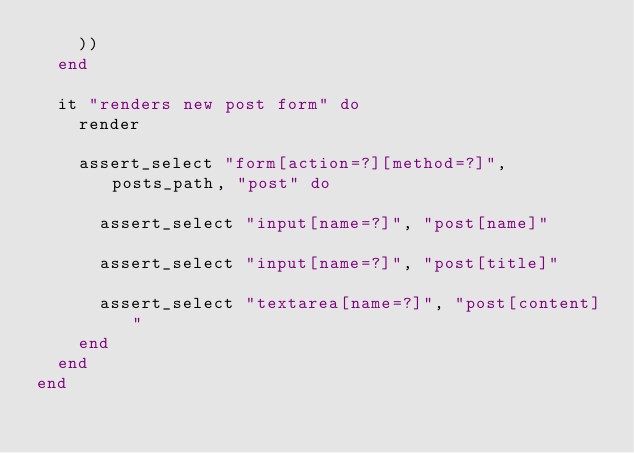Convert code to text. <code><loc_0><loc_0><loc_500><loc_500><_Ruby_>    ))
  end

  it "renders new post form" do
    render

    assert_select "form[action=?][method=?]", posts_path, "post" do

      assert_select "input[name=?]", "post[name]"

      assert_select "input[name=?]", "post[title]"

      assert_select "textarea[name=?]", "post[content]"
    end
  end
end
</code> 